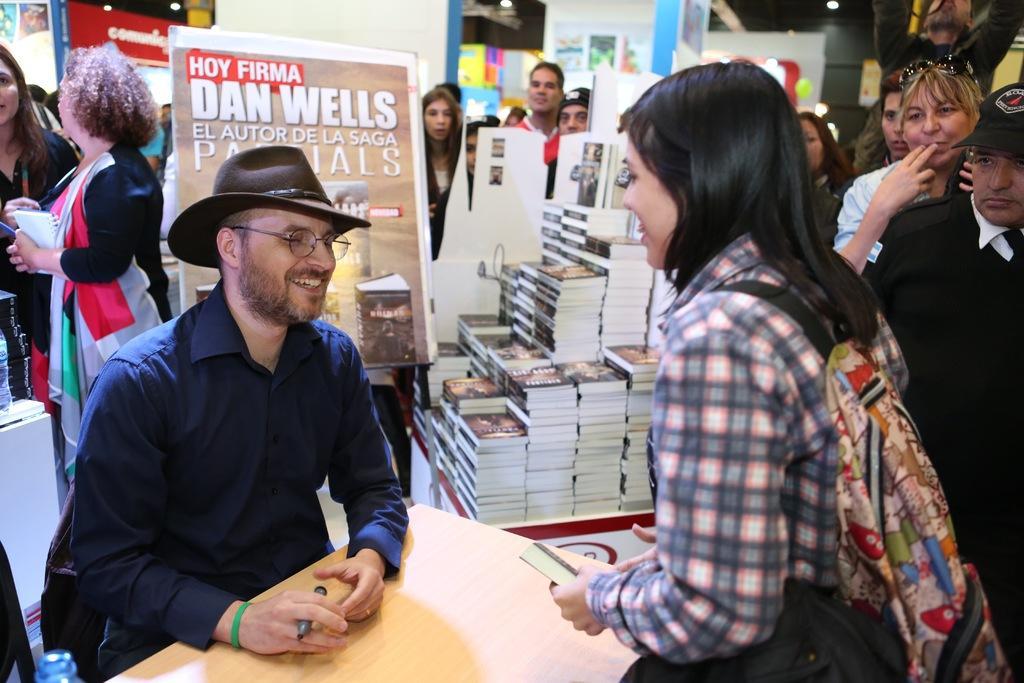Could you give a brief overview of what you see in this image? In this picture we can see a group of people, books, posters, bottle, table, bag, goggles, pen, cap and a man wore a hat, spectacle and sitting on a chair and smiling and some objects and in the background we can see the lights. 